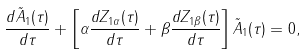<formula> <loc_0><loc_0><loc_500><loc_500>\frac { d \tilde { A } _ { 1 } ( \tau ) } { d \tau } + \left [ \alpha \frac { d Z _ { 1 \alpha } ( \tau ) } { d \tau } + \beta \frac { d Z _ { 1 \beta } ( \tau ) } { d \tau } \right ] \tilde { A } _ { 1 } ( \tau ) = 0 ,</formula> 